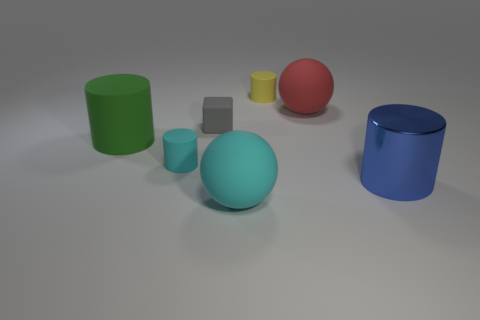Subtract all brown cylinders. Subtract all cyan spheres. How many cylinders are left? 4 Add 2 small yellow cylinders. How many objects exist? 9 Subtract all blocks. How many objects are left? 6 Add 1 matte objects. How many matte objects are left? 7 Add 4 small blocks. How many small blocks exist? 5 Subtract 0 brown cylinders. How many objects are left? 7 Subtract all tiny yellow objects. Subtract all gray matte cubes. How many objects are left? 5 